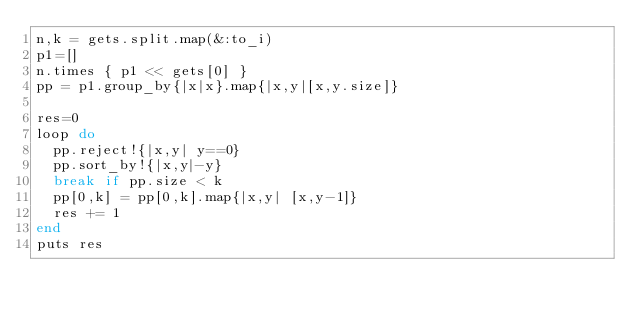Convert code to text. <code><loc_0><loc_0><loc_500><loc_500><_Ruby_>n,k = gets.split.map(&:to_i)
p1=[]
n.times { p1 << gets[0] }
pp = p1.group_by{|x|x}.map{|x,y|[x,y.size]}

res=0
loop do
  pp.reject!{|x,y| y==0}
  pp.sort_by!{|x,y|-y}
  break if pp.size < k
  pp[0,k] = pp[0,k].map{|x,y| [x,y-1]}
  res += 1
end
puts res
</code> 